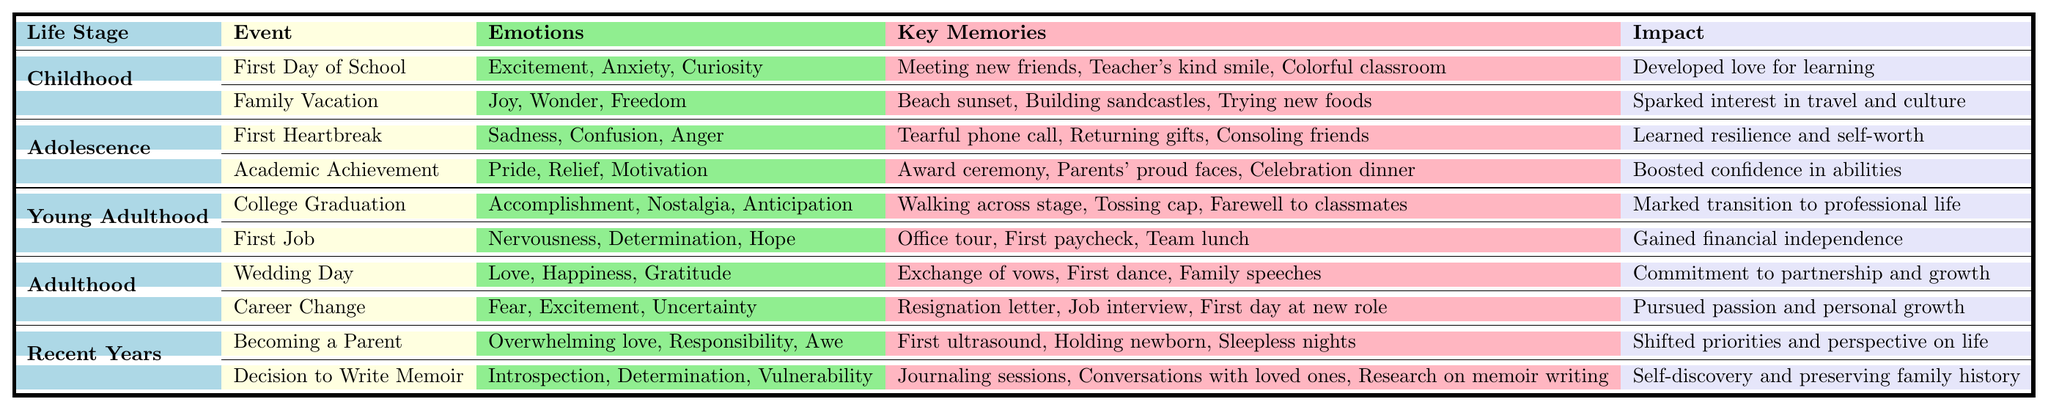What emotions are associated with the event "Family Vacation"? The table lists "Joy," "Wonder," and "Freedom" as the emotions associated with the "Family Vacation" event in Childhood.
Answer: Joy, Wonder, Freedom Which key memory is linked to the "First Heartbreak"? The key memory associated with "First Heartbreak" is "Tearful phone call," which is specifically mentioned in the Adolescence section of the table.
Answer: Tearful phone call How many key memories are listed for the event "Decision to Write Memoir"? The event "Decision to Write Memoir" has three key memories associated with it: "Journaling sessions," "Conversations with loved ones," and "Research on memoir writing."
Answer: 3 Which life stage does the event "College Graduation" belong to? The event "College Graduation" is found under the life stage labeled "Young Adulthood" in the table.
Answer: Young Adulthood What is the impact of the "First Job" event? The table indicates that the impact of the "First Job" event is "Gained financial independence."
Answer: Gained financial independence Are the emotions associated with "Career Change" all positive? No, the emotions for "Career Change" include "Fear," which is a negative emotion, along with "Excitement" and "Uncertainty."
Answer: No List the emotions associated with "Becoming a Parent". The emotions connected to "Becoming a Parent" are "Overwhelming love," "Responsibility," and "Awe," as specified in the Recent Years section of the table.
Answer: Overwhelming love, Responsibility, Awe What is the impact of "Academic Achievement" compared to "First Heartbreak"? The impact of "Academic Achievement" is "Boosted confidence in abilities," while "First Heartbreak" has an impact of "Learned resilience and self-worth"; both indicate different outcomes in personal growth.
Answer: Different outcomes in personal growth Which events share the emotion "Determination"? The events "First Job" and "Decision to Write Memoir" both include "Determination" among their associated emotions, demonstrating a common feeling during different life stages.
Answer: First Job, Decision to Write Memoir How many emotions are listed for the event "Wedding Day"? For the event "Wedding Day," three emotions are listed: "Love," "Happiness," and "Gratitude." Therefore, the answer is 3.
Answer: 3 Explain how the events in the "Recent Years" category compare in terms of key memories. "Becoming a Parent" has three key memories: "First ultrasound," "Holding newborn," and "Sleepless nights," while "Decision to Write Memoir" also has three key memories: "Journaling sessions," "Conversations with loved ones," and "Research on memoir writing," indicating they are equal in this aspect.
Answer: They are equal; both have 3 key memories 